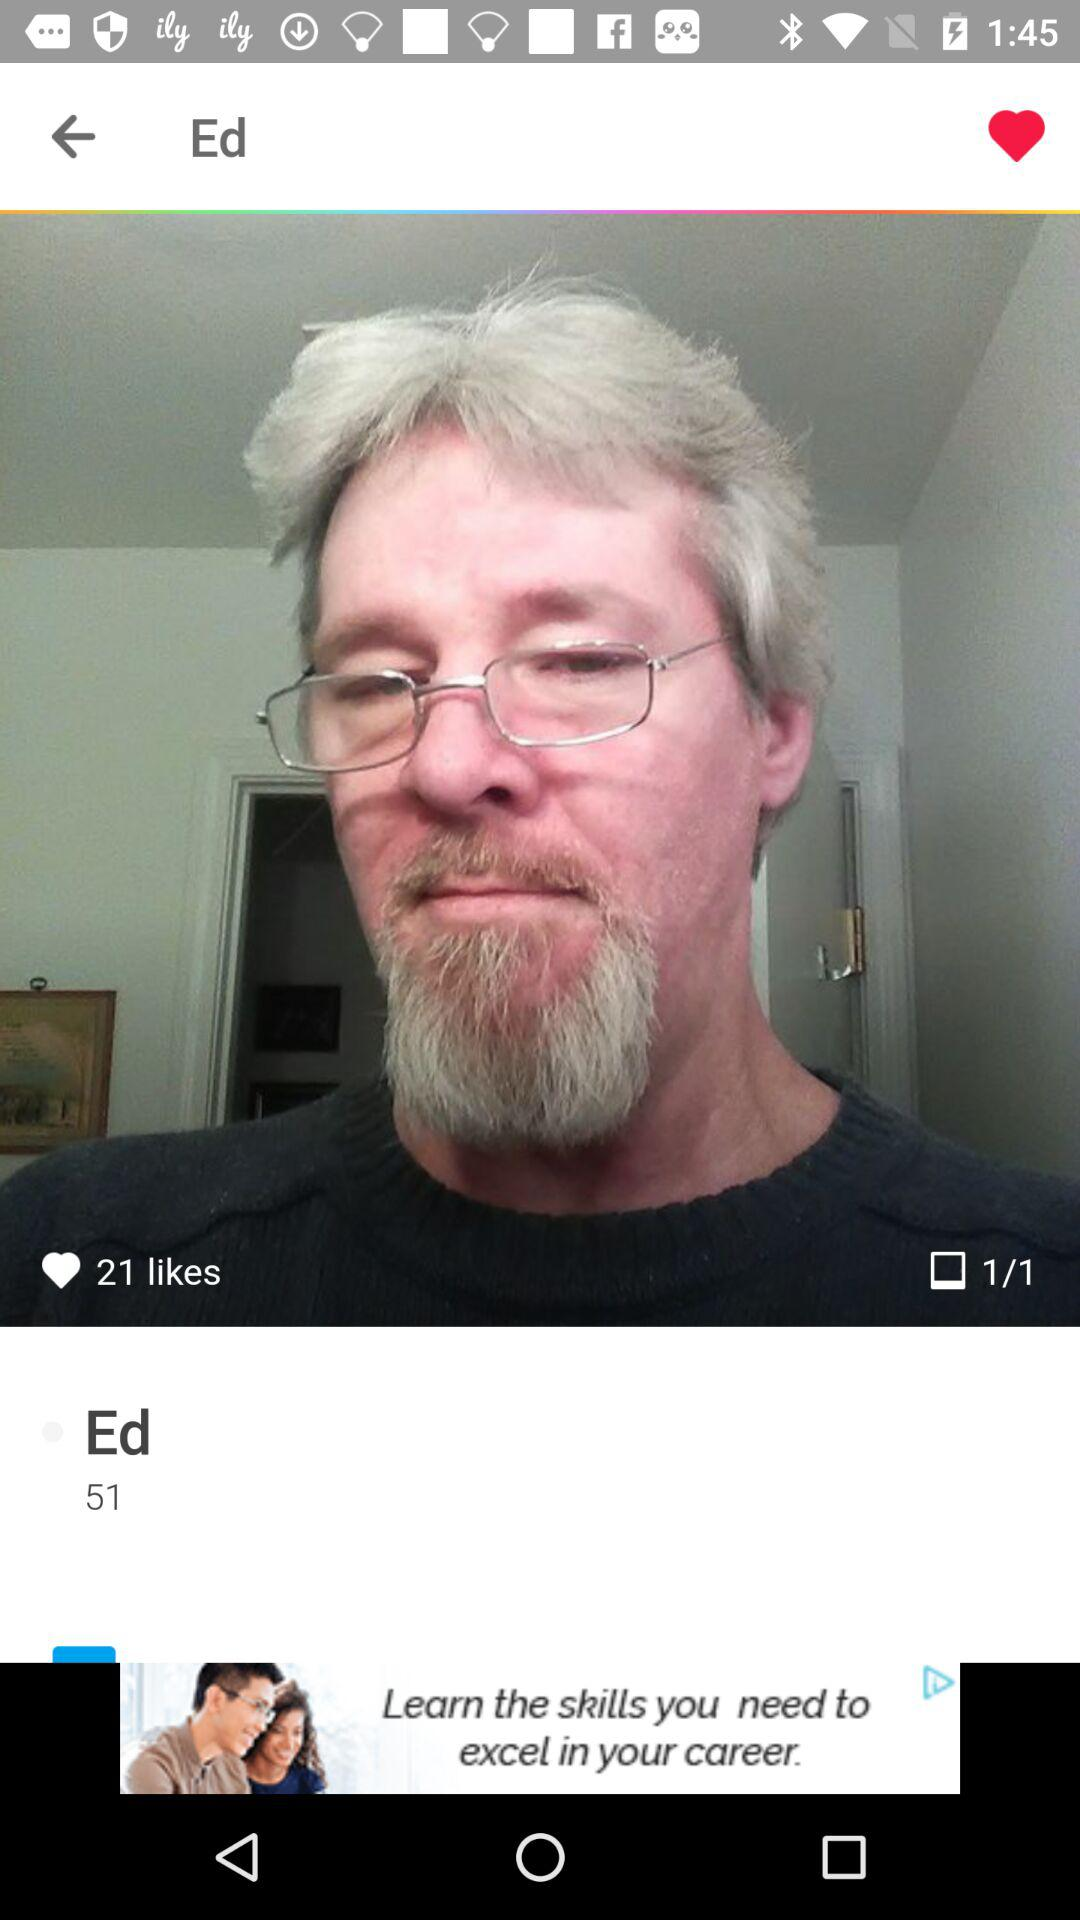What is the age of Ed? The age of Ed is 51. 